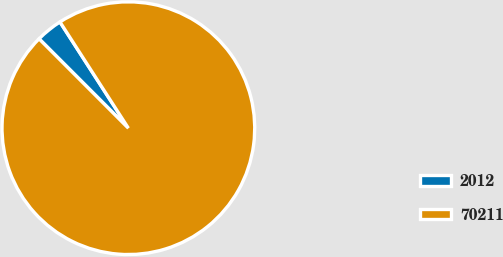<chart> <loc_0><loc_0><loc_500><loc_500><pie_chart><fcel>2012<fcel>70211<nl><fcel>3.39%<fcel>96.61%<nl></chart> 